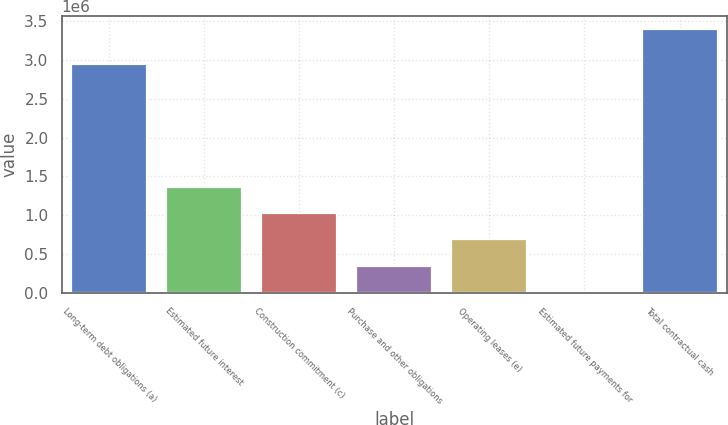<chart> <loc_0><loc_0><loc_500><loc_500><bar_chart><fcel>Long-term debt obligations (a)<fcel>Estimated future interest<fcel>Construction commitment (c)<fcel>Purchase and other obligations<fcel>Operating leases (e)<fcel>Estimated future payments for<fcel>Total contractual cash<nl><fcel>2.94383e+06<fcel>1.36783e+06<fcel>1.02947e+06<fcel>352738<fcel>691103<fcel>14373<fcel>3.39802e+06<nl></chart> 